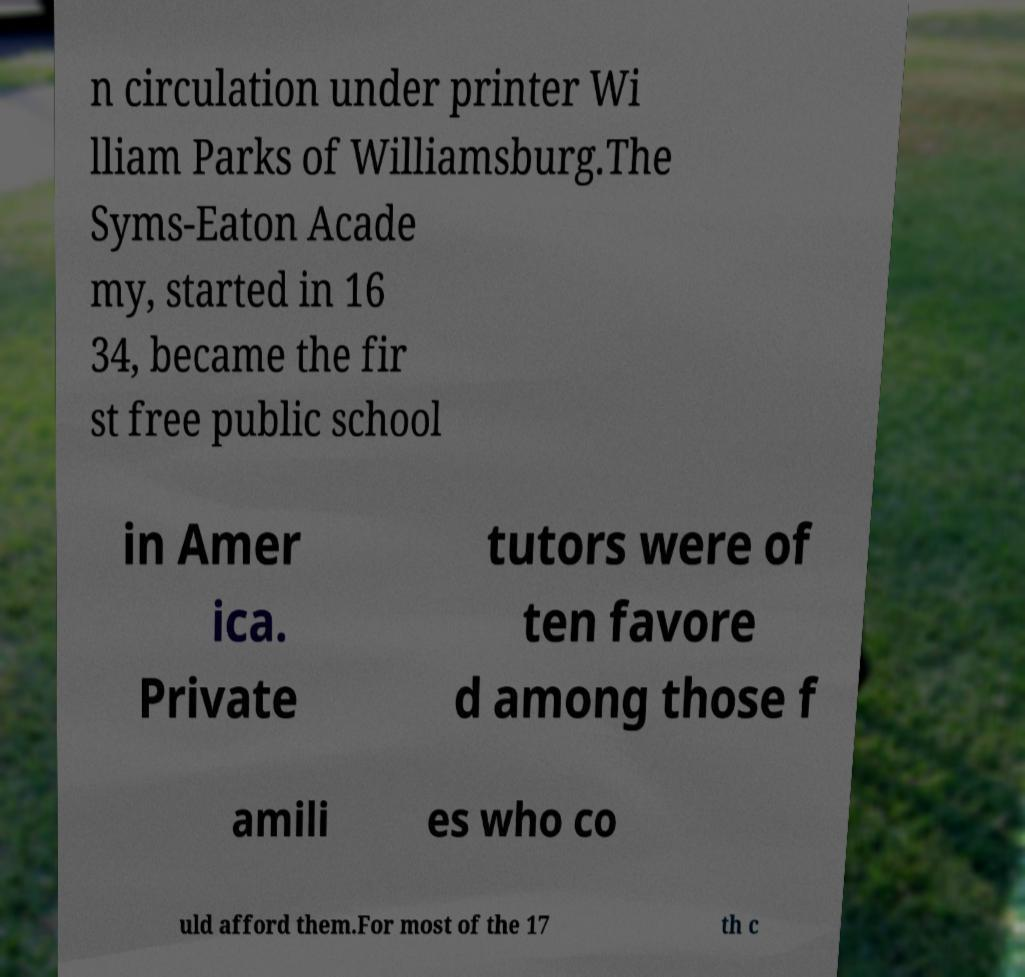Could you extract and type out the text from this image? n circulation under printer Wi lliam Parks of Williamsburg.The Syms-Eaton Acade my, started in 16 34, became the fir st free public school in Amer ica. Private tutors were of ten favore d among those f amili es who co uld afford them.For most of the 17 th c 